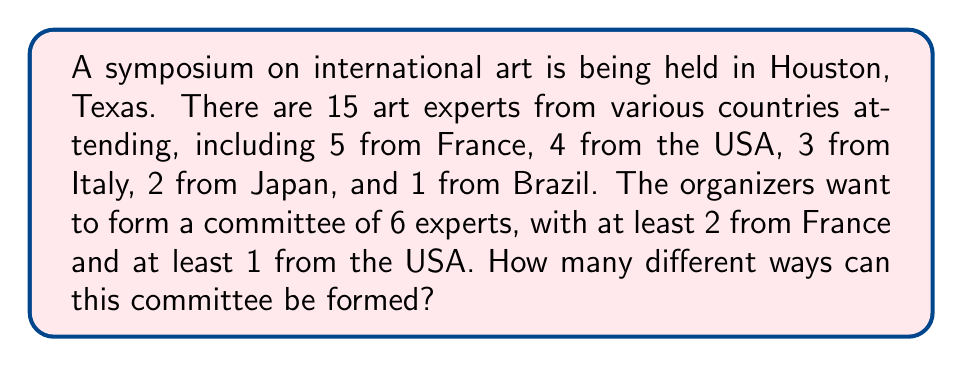Solve this math problem. Let's approach this step-by-step:

1) First, we need to select at least 2 French experts and at least 1 US expert. Let's consider the cases:

   Case 1: 2 French and 1 US expert
   Case 2: 3 French and 1 US expert
   Case 3: 2 French and 2 US expert
   Case 4: 3 French and 2 US expert
   Case 5: 4 French and 1 US expert
   Case 6: 5 French and 1 US expert

2) Let's calculate each case:

   Case 1: $\binom{5}{2} \cdot \binom{4}{1} \cdot \binom{6}{3} = 10 \cdot 4 \cdot 20 = 800$
   
   Case 2: $\binom{5}{3} \cdot \binom{4}{1} \cdot \binom{6}{2} = 10 \cdot 4 \cdot 15 = 600$
   
   Case 3: $\binom{5}{2} \cdot \binom{4}{2} \cdot \binom{6}{2} = 10 \cdot 6 \cdot 15 = 900$
   
   Case 4: $\binom{5}{3} \cdot \binom{4}{2} \cdot \binom{6}{1} = 10 \cdot 6 \cdot 6 = 360$
   
   Case 5: $\binom{5}{4} \cdot \binom{4}{1} \cdot \binom{6}{1} = 5 \cdot 4 \cdot 6 = 120$
   
   Case 6: $\binom{5}{5} \cdot \binom{4}{1} = 1 \cdot 4 = 4$

3) The total number of ways is the sum of all these cases:

   $800 + 600 + 900 + 360 + 120 + 4 = 2784$

Therefore, there are 2784 different ways to form the committee.
Answer: 2784 